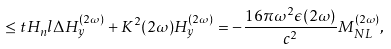Convert formula to latex. <formula><loc_0><loc_0><loc_500><loc_500>\leq t { H _ { n } l } \Delta H _ { y } ^ { ( 2 \omega ) } + K ^ { 2 } ( 2 \omega ) H _ { y } ^ { ( 2 \omega ) } = - \frac { 1 6 \pi \omega ^ { 2 } \epsilon ( 2 \omega ) } { c ^ { 2 } } M _ { N L } ^ { ( 2 \omega ) } ,</formula> 